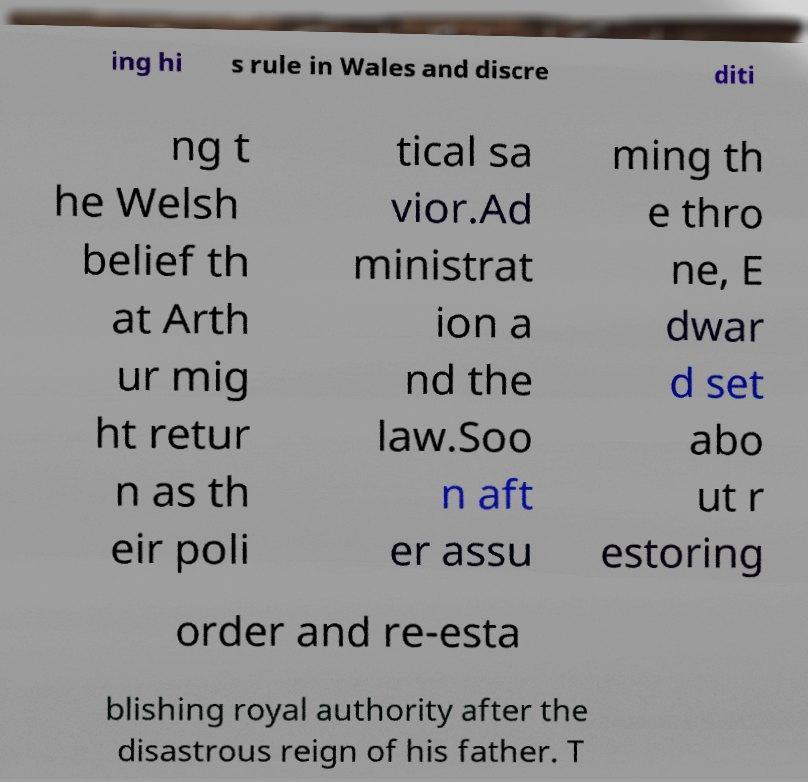Can you read and provide the text displayed in the image?This photo seems to have some interesting text. Can you extract and type it out for me? ing hi s rule in Wales and discre diti ng t he Welsh belief th at Arth ur mig ht retur n as th eir poli tical sa vior.Ad ministrat ion a nd the law.Soo n aft er assu ming th e thro ne, E dwar d set abo ut r estoring order and re-esta blishing royal authority after the disastrous reign of his father. T 